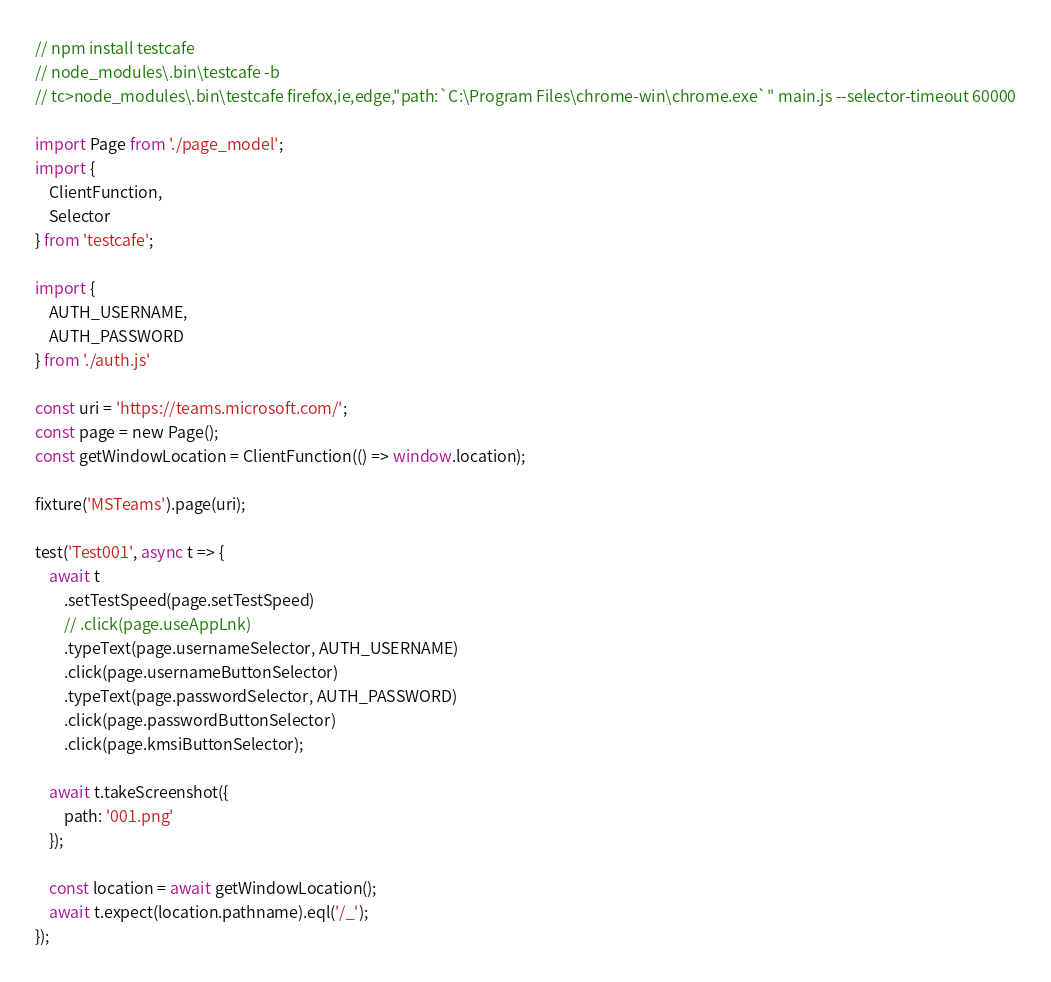<code> <loc_0><loc_0><loc_500><loc_500><_JavaScript_>// npm install testcafe
// node_modules\.bin\testcafe -b
// tc>node_modules\.bin\testcafe firefox,ie,edge,"path:`C:\Program Files\chrome-win\chrome.exe`" main.js --selector-timeout 60000

import Page from './page_model';
import {
    ClientFunction,
    Selector
} from 'testcafe';

import {
    AUTH_USERNAME,
    AUTH_PASSWORD
} from './auth.js'

const uri = 'https://teams.microsoft.com/';
const page = new Page();
const getWindowLocation = ClientFunction(() => window.location);

fixture('MSTeams').page(uri);

test('Test001', async t => {
    await t
        .setTestSpeed(page.setTestSpeed)
        // .click(page.useAppLnk)
        .typeText(page.usernameSelector, AUTH_USERNAME)
        .click(page.usernameButtonSelector)
        .typeText(page.passwordSelector, AUTH_PASSWORD)
        .click(page.passwordButtonSelector)
        .click(page.kmsiButtonSelector);

    await t.takeScreenshot({
        path: '001.png'
    });

    const location = await getWindowLocation();
    await t.expect(location.pathname).eql('/_');
});</code> 